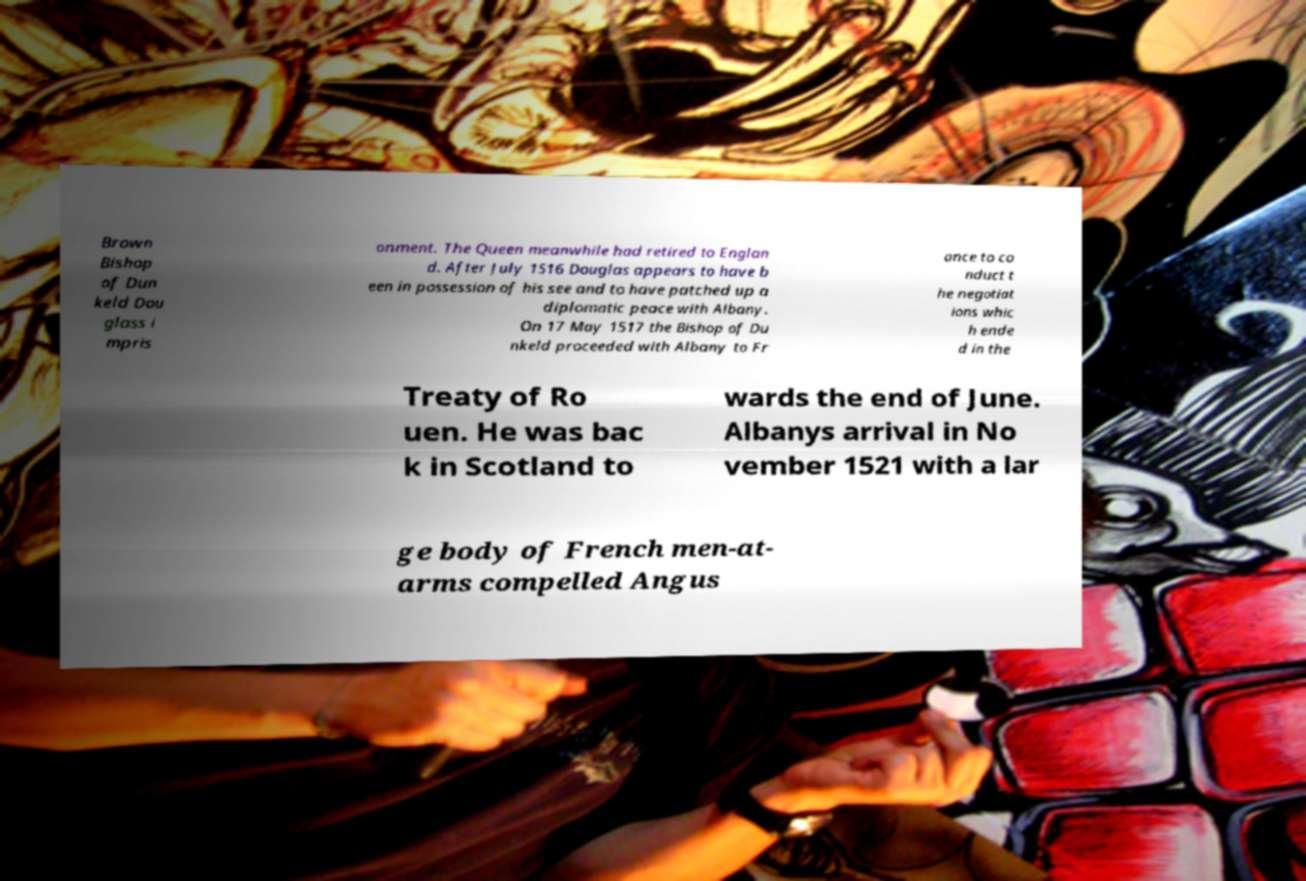For documentation purposes, I need the text within this image transcribed. Could you provide that? Brown Bishop of Dun keld Dou glass i mpris onment. The Queen meanwhile had retired to Englan d. After July 1516 Douglas appears to have b een in possession of his see and to have patched up a diplomatic peace with Albany. On 17 May 1517 the Bishop of Du nkeld proceeded with Albany to Fr ance to co nduct t he negotiat ions whic h ende d in the Treaty of Ro uen. He was bac k in Scotland to wards the end of June. Albanys arrival in No vember 1521 with a lar ge body of French men-at- arms compelled Angus 